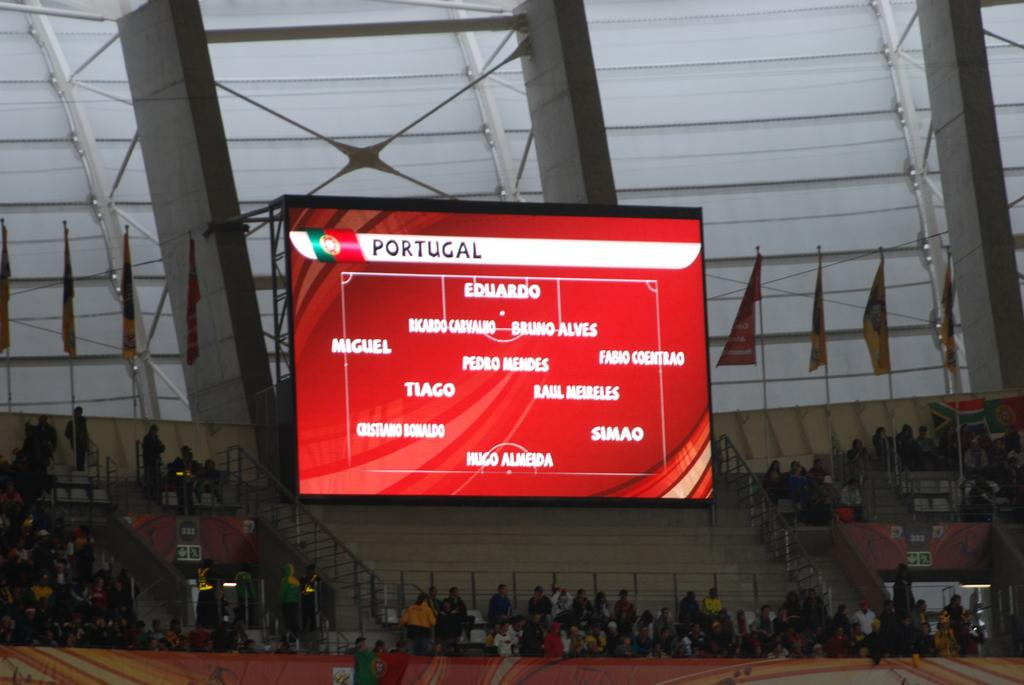<image>
Describe the image concisely. A red sign shows the standing of Portugal. 